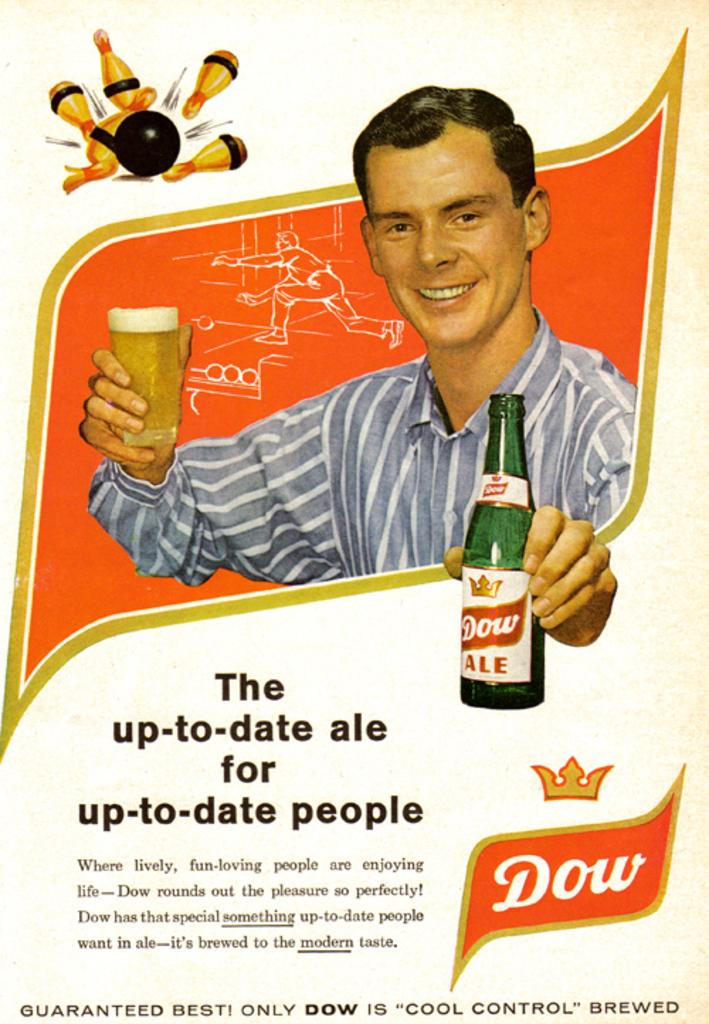Provide a one-sentence caption for the provided image. An advertisement from Dow ale for up-to-date people. 